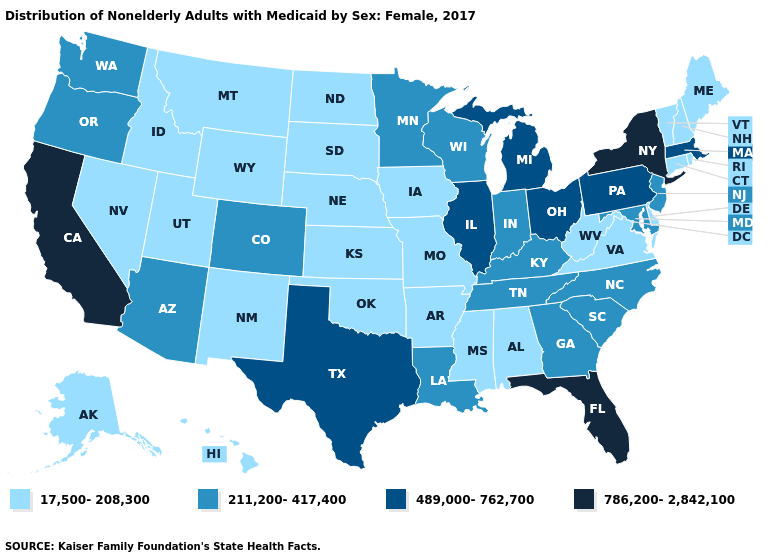Which states have the lowest value in the Northeast?
Keep it brief. Connecticut, Maine, New Hampshire, Rhode Island, Vermont. What is the value of Maryland?
Answer briefly. 211,200-417,400. Name the states that have a value in the range 489,000-762,700?
Keep it brief. Illinois, Massachusetts, Michigan, Ohio, Pennsylvania, Texas. What is the lowest value in states that border Rhode Island?
Be succinct. 17,500-208,300. Among the states that border Missouri , does Kansas have the lowest value?
Concise answer only. Yes. Name the states that have a value in the range 786,200-2,842,100?
Short answer required. California, Florida, New York. What is the highest value in states that border Alabama?
Be succinct. 786,200-2,842,100. What is the value of Massachusetts?
Quick response, please. 489,000-762,700. Among the states that border Louisiana , does Texas have the lowest value?
Be succinct. No. Does Florida have the same value as Pennsylvania?
Give a very brief answer. No. Does the map have missing data?
Short answer required. No. What is the value of South Dakota?
Give a very brief answer. 17,500-208,300. What is the value of Tennessee?
Give a very brief answer. 211,200-417,400. Does the first symbol in the legend represent the smallest category?
Short answer required. Yes. Among the states that border Wyoming , does Idaho have the lowest value?
Write a very short answer. Yes. 